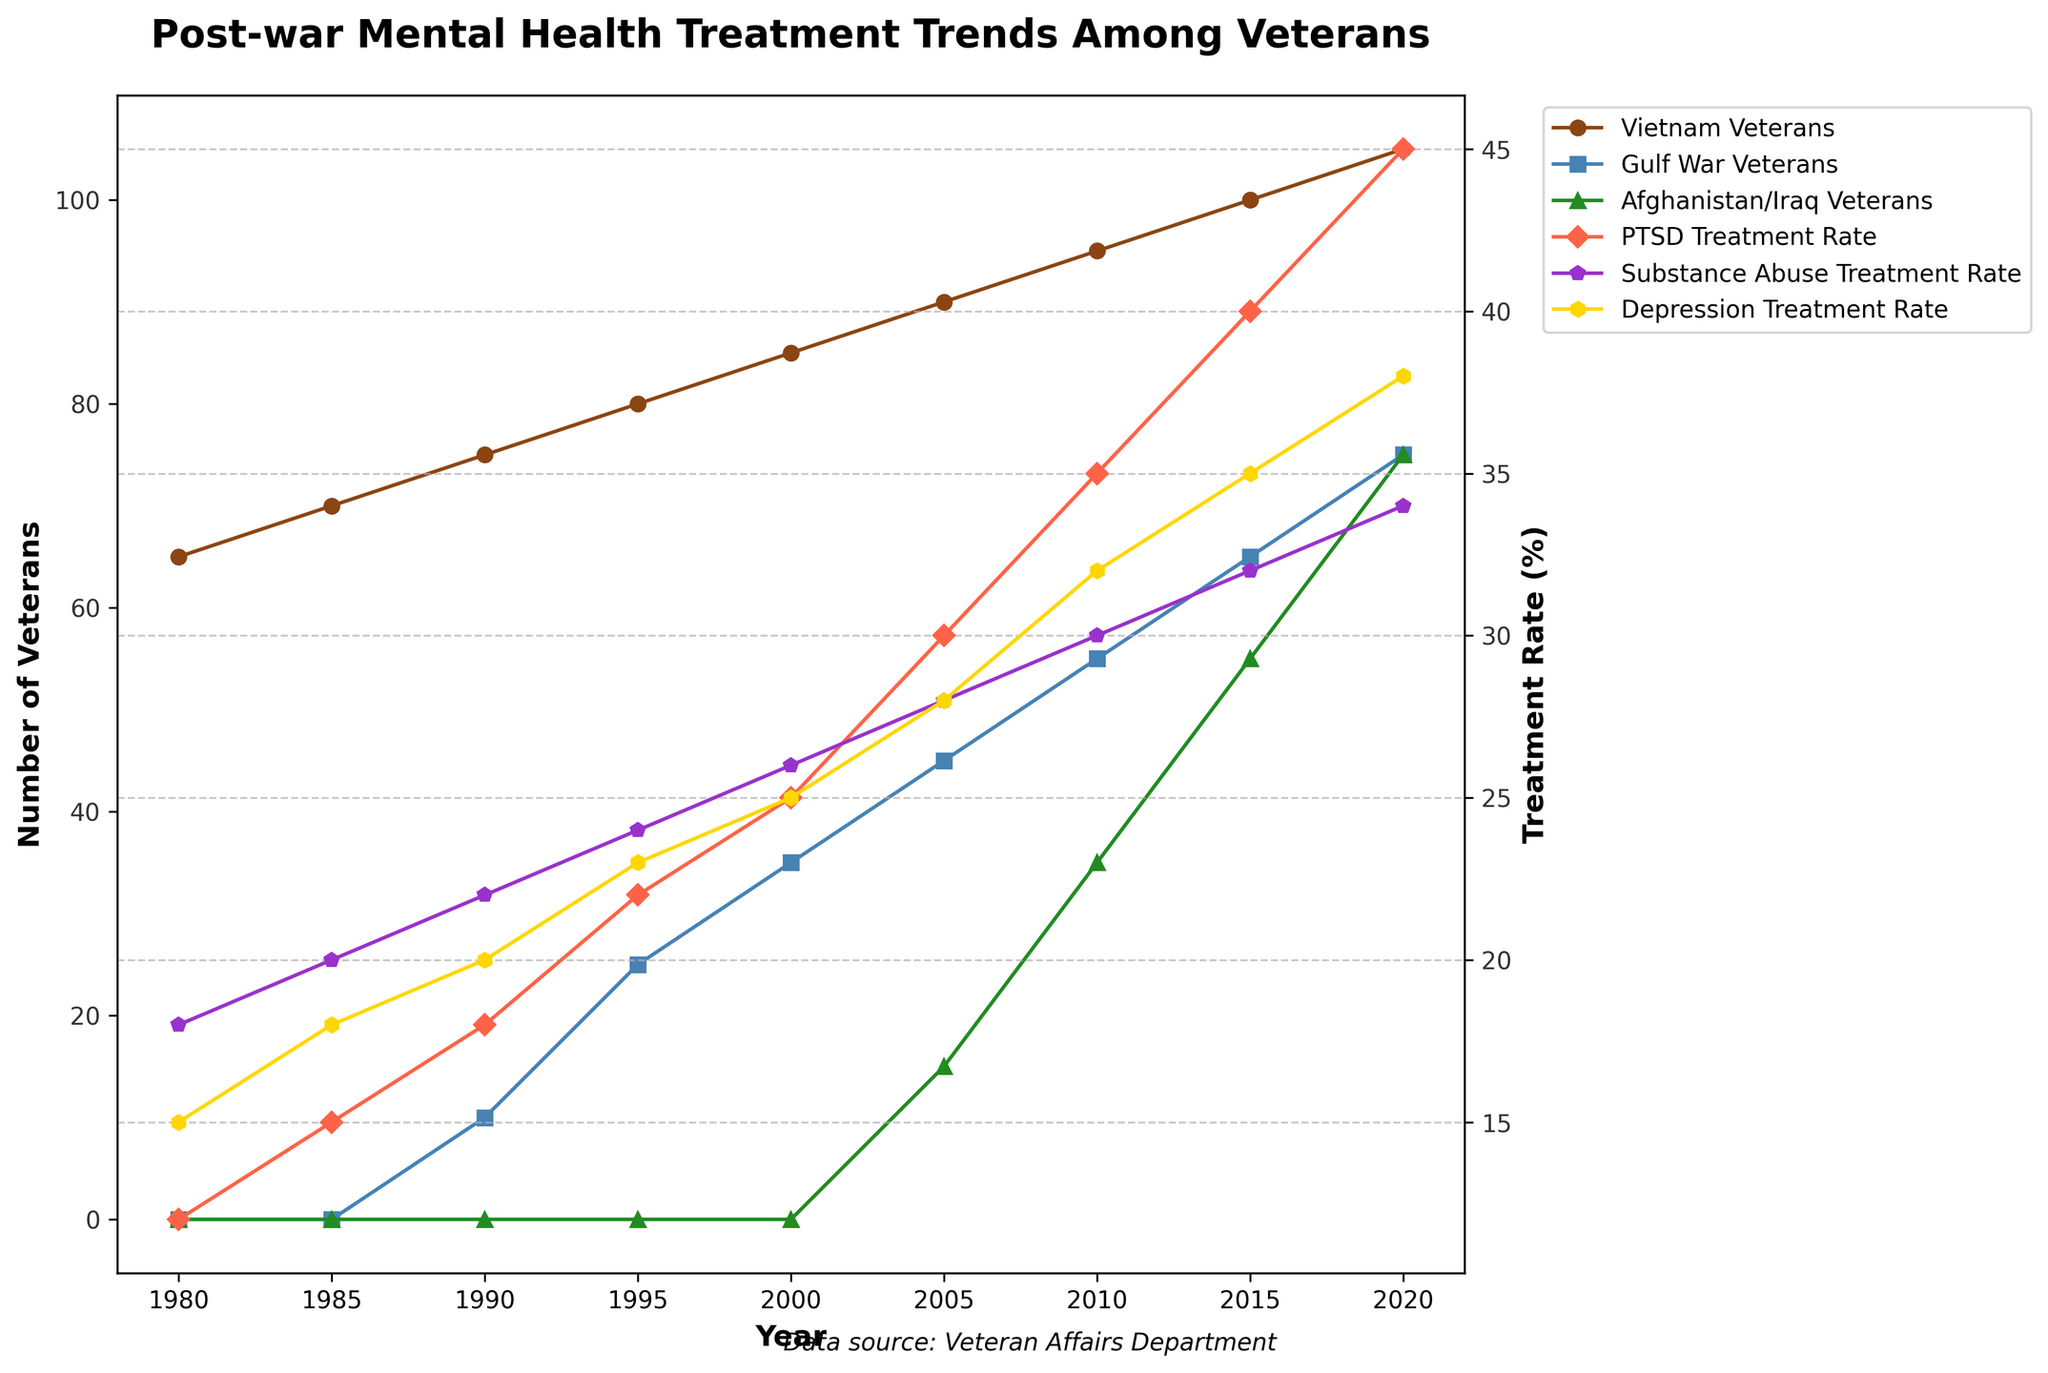What year did the number of Afghanistan/Iraq Veterans reach 75? To answer the question, look at the line representing Afghanistan/Iraq Veterans. The value reaches 75 in the year corresponding to the point where this line crosses 75.
Answer: 2020 In which decade did the PTSD Treatment Rate see the greatest increase? Identify the PTSD Treatment Rate line and compare the increase between each decade by noting the points at the decade marks (1980, 1990, 2000, 2010, 2020). The greatest decade-over-decade increase occurred between 2000 and 2010. The increase from 25% in 2000 to 35% in 2010 is significantly larger than other decades.
Answer: 2000-2010 Which group of veterans has consistently had the highest numbers from 1980 through 2020? Examine the lines representing Vietnam Veterans, Gulf War Veterans, and Afghanistan/Iraq Veterans. The line for Vietnam Veterans is consistently the highest across all years in the chart.
Answer: Vietnam Veterans How does the number of Gulf War Veterans in 2000 compare to Afghanistan/Iraq Veterans in 2010? The number of Gulf War Veterans in 2000 is represented by the point on the Gulf War line for the year 2000, which is 35. The number of Afghanistan/Iraq Veterans in 2010 is represented by the point on the Afghanistan/Iraq Veterans line for the year 2010, which is 35. Both values are the same.
Answer: Equal (both 35) What is the difference in PTSD Treatment Rate between 1980 and 2020? Locate the PTSD Treatment Rate line. Find the values at 1980 (12%) and at 2020 (45%). Subtract the 1980 value from the 2020 value: 45% - 12% = 33%.
Answer: 33% Between 2015 and 2020, which treatment rate increased the most? Examine the treatment rates (PTSD, Substance Abuse, Depression) for 2015 and 2020. Calculate the differences: PTSD (45% - 40% = 5%), Substance Abuse (34% - 32% = 2%), and Depression (38% - 35% = 3%). The PTSD Treatment Rate increased the most by 5%.
Answer: PTSD What are the numerical values of Depression Treatment Rate in 2005 and 2020? Identify the Depression Treatment Rate line and read the value at the points for the years 2005 and 2020. The values are 28% (2005) and 38% (2020).
Answer: 28% (2005) and 38% (2020) During which year did Gulf War Veterans and Afghanistan/Iraq Veterans have the same number, and what was the number? Observe the lines representing Gulf War Veterans and Afghanistan/Iraq Veterans and find the intersection point where they have the same value. This occurred in 2010, where both had 35 veterans.
Answer: 2010 and 35 How do the treatment rates for Depression and Substance Abuse compare in 1985? Look at the values for Depression and Substance Abuse Treatment Rates in 1985. Depression Treatment Rate is 18%, and Substance Abuse Treatment Rate is 20%. Compare the two values: Substance Abuse Treatment Rate (20%) is higher than Depression Treatment Rate (18%).
Answer: Substance Abuse Treatment Rate is higher (20% vs. 18%) What is the average number of Vietnam Veterans in 1990, 2000, and 2010? Take the values of Vietnam Veterans for the years 1990 (75), 2000 (85), and 2010 (95). Sum them up and divide by 3: (75 + 85 + 95) / 3 = 255 / 3 = 85.
Answer: 85 